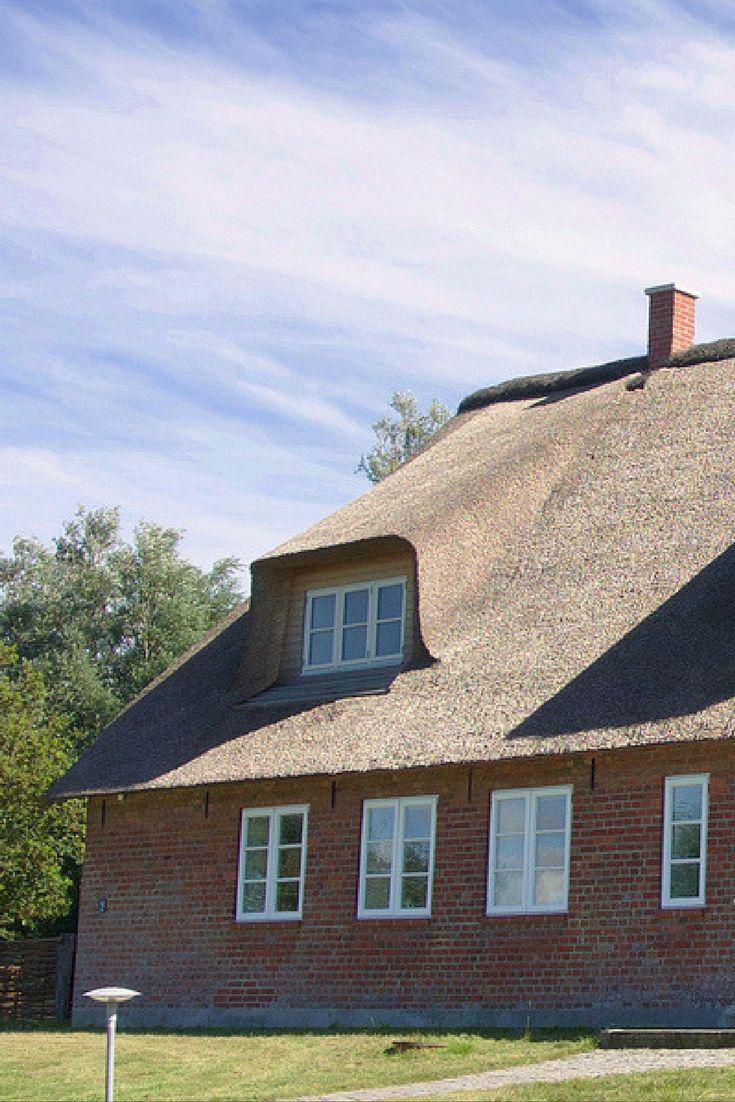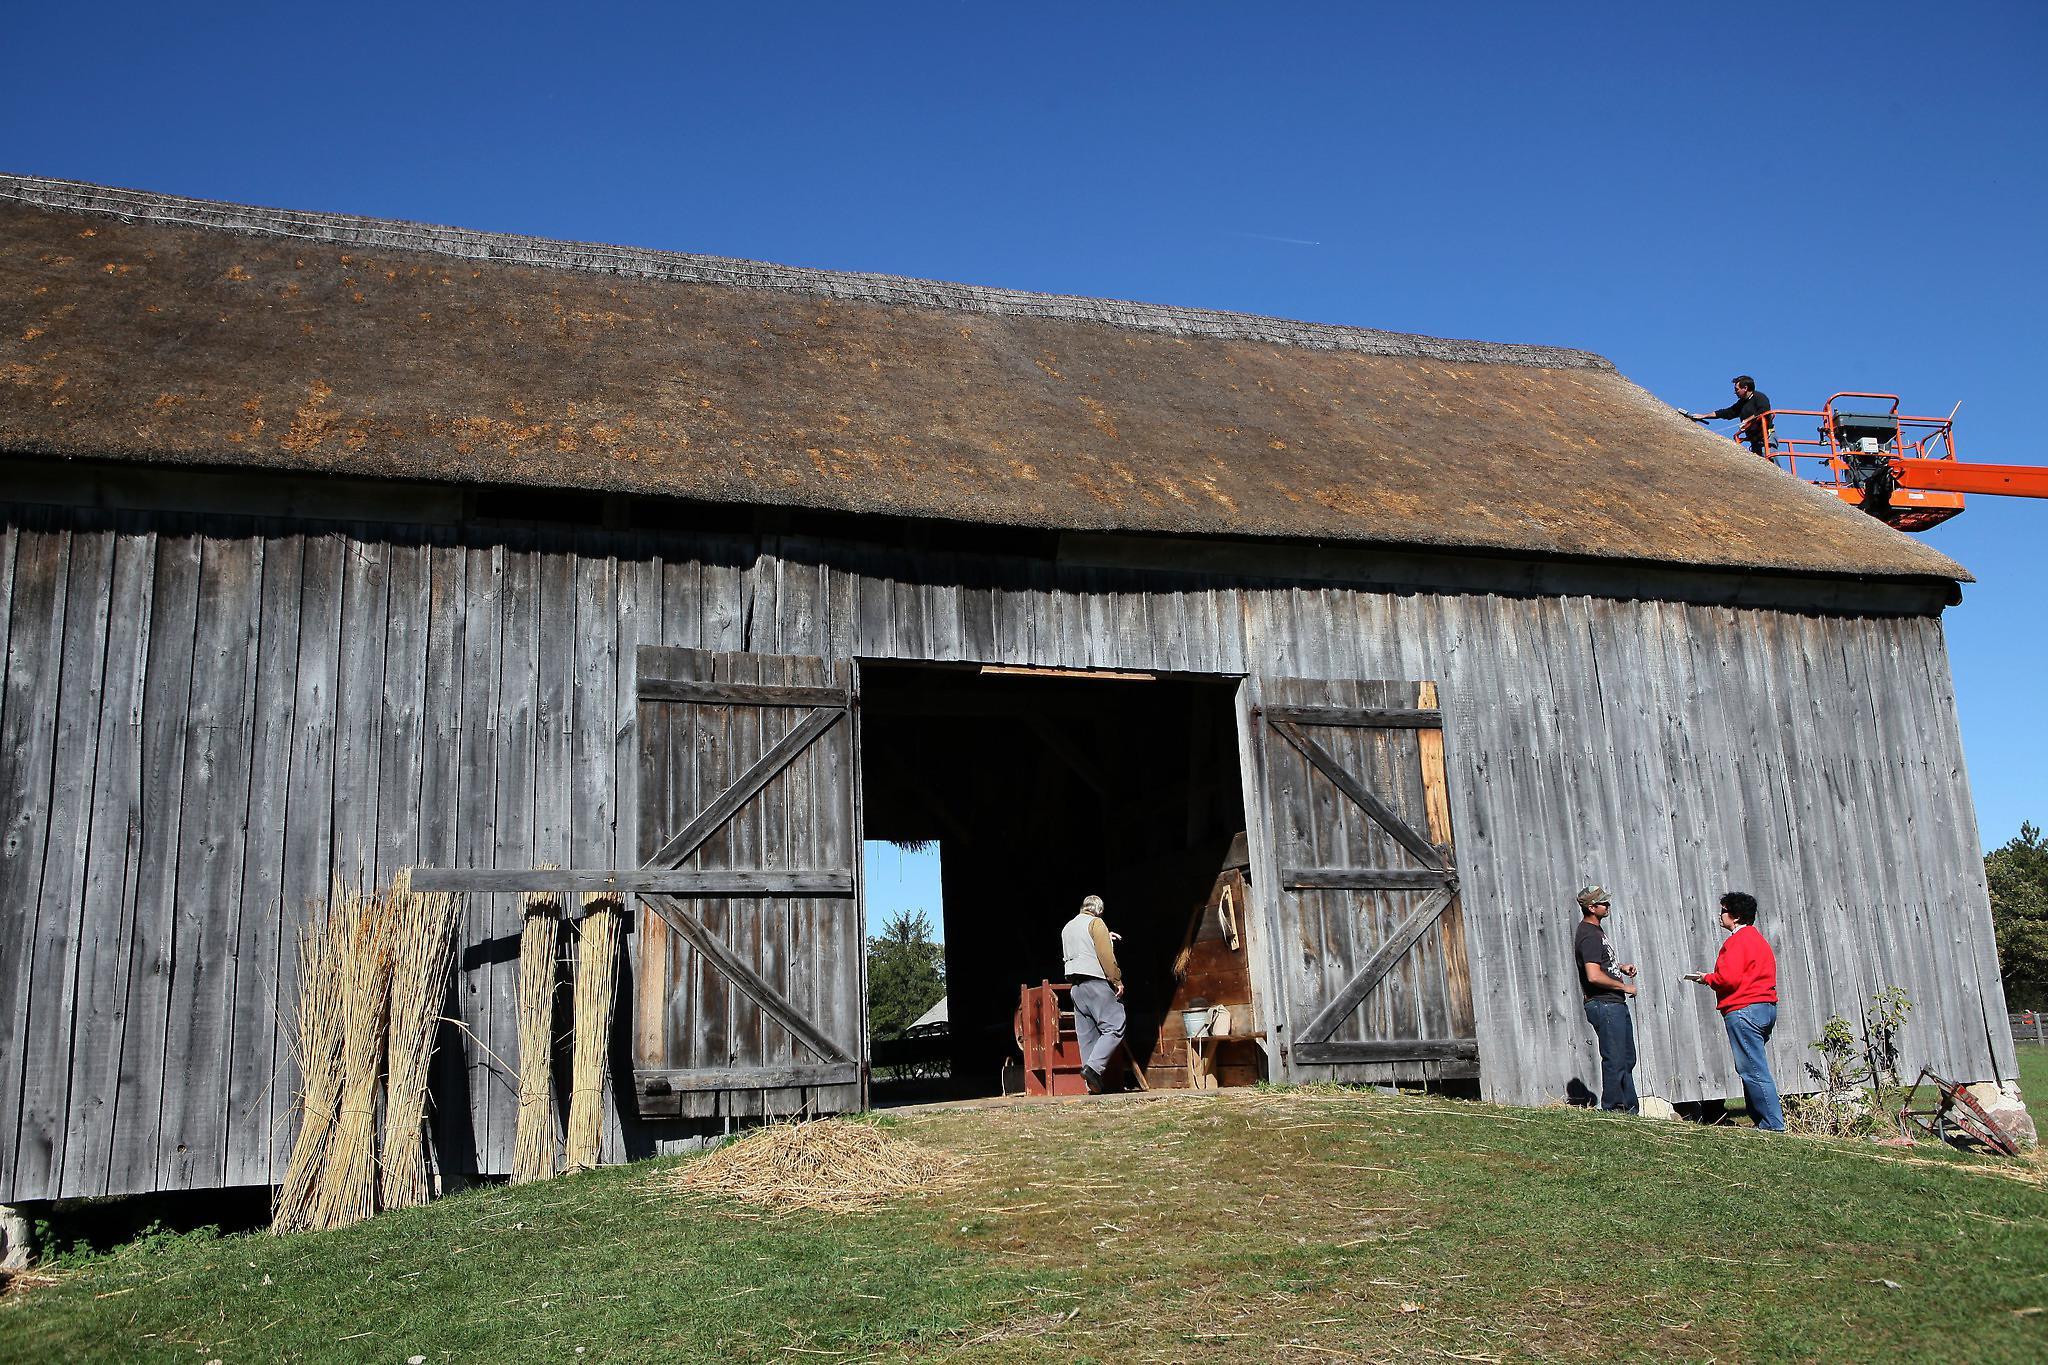The first image is the image on the left, the second image is the image on the right. Assess this claim about the two images: "The building in the image on the left has a chimney.". Correct or not? Answer yes or no. Yes. The first image is the image on the left, the second image is the image on the right. For the images displayed, is the sentence "The right image shows a long grey building with a peaked roof and an open door, but no windows, and the left image shows a building with a peaked roof and windows on the front." factually correct? Answer yes or no. Yes. 